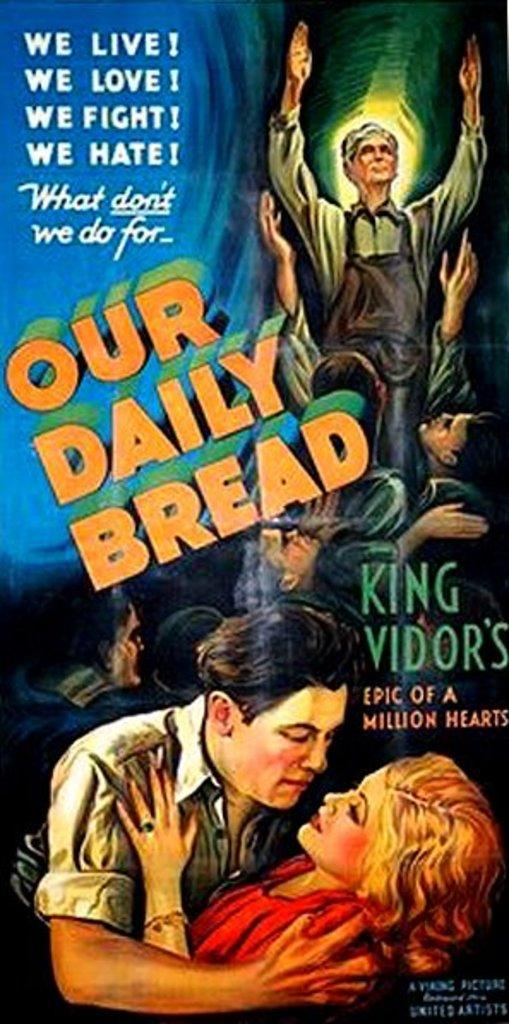Provide a one-sentence caption for the provided image. Poster which shows a man and a woman hugging with the words "We Live!" on top. 